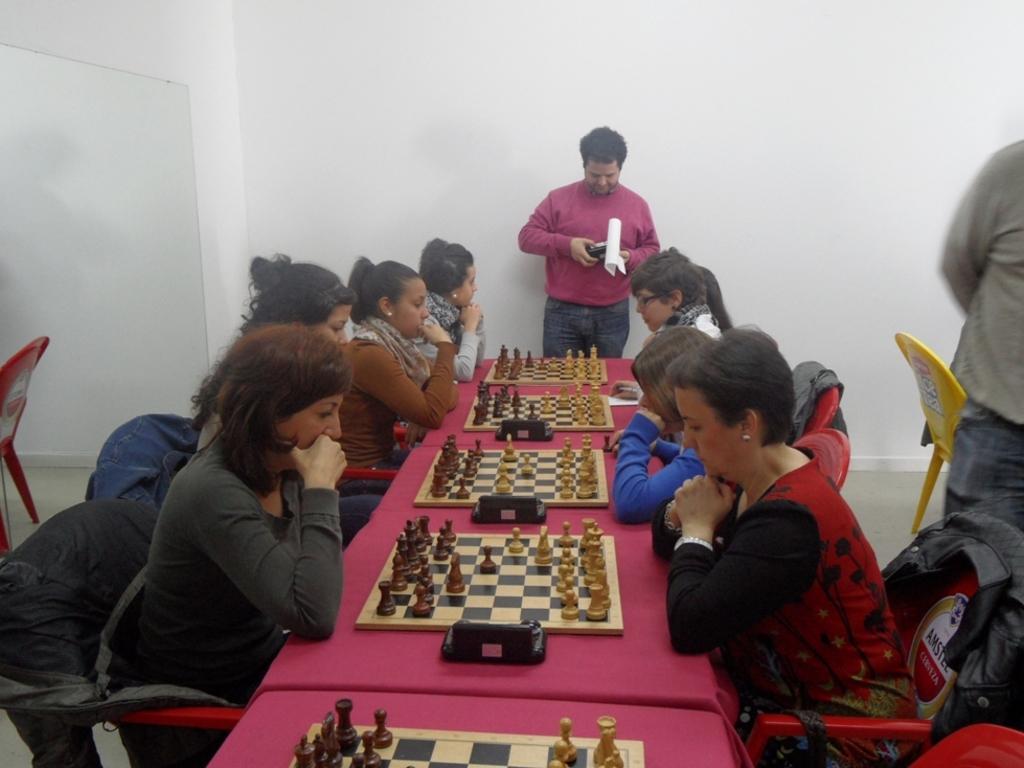Describe this image in one or two sentences. In this image there are group of persons who are playing chess and at the background of the image there is a person standing. 